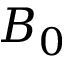Convert formula to latex. <formula><loc_0><loc_0><loc_500><loc_500>B _ { 0 }</formula> 